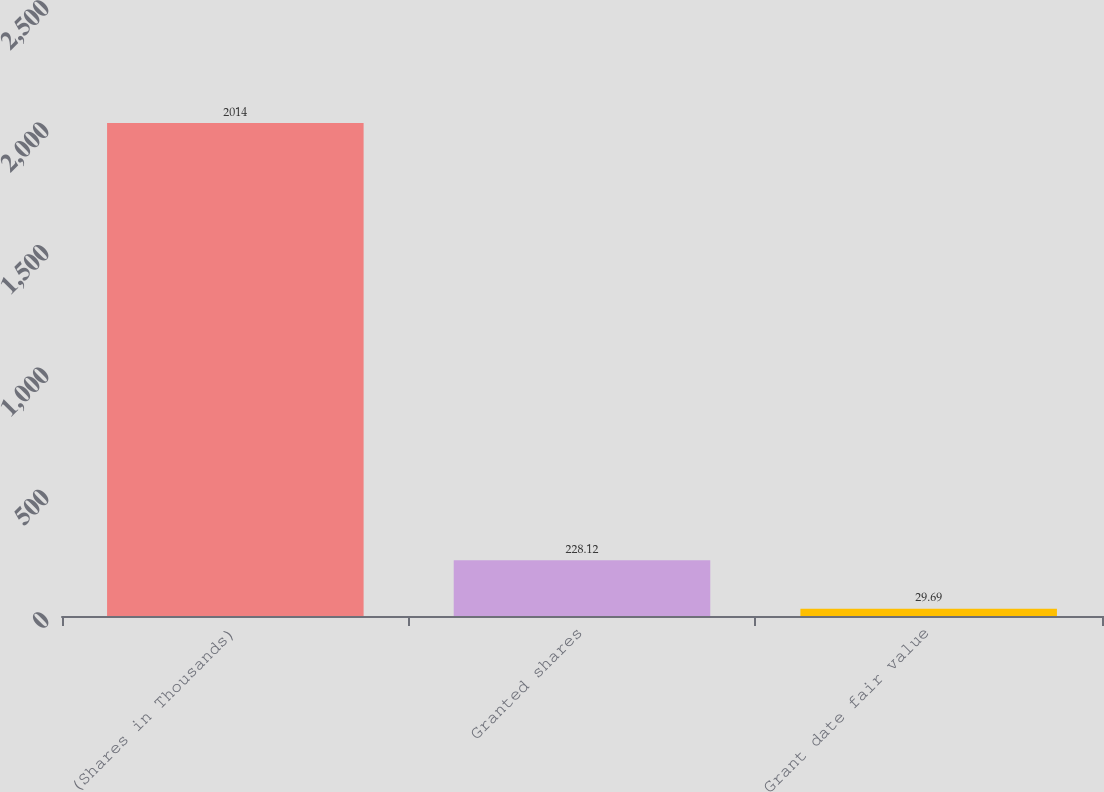<chart> <loc_0><loc_0><loc_500><loc_500><bar_chart><fcel>(Shares in Thousands)<fcel>Granted shares<fcel>Grant date fair value<nl><fcel>2014<fcel>228.12<fcel>29.69<nl></chart> 